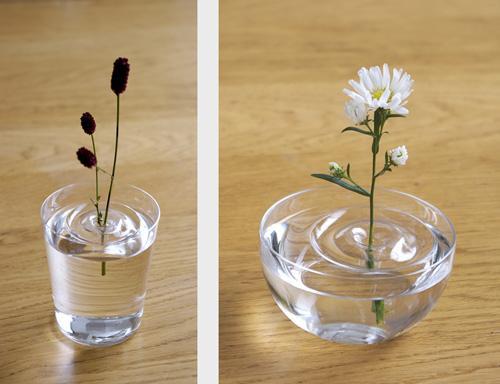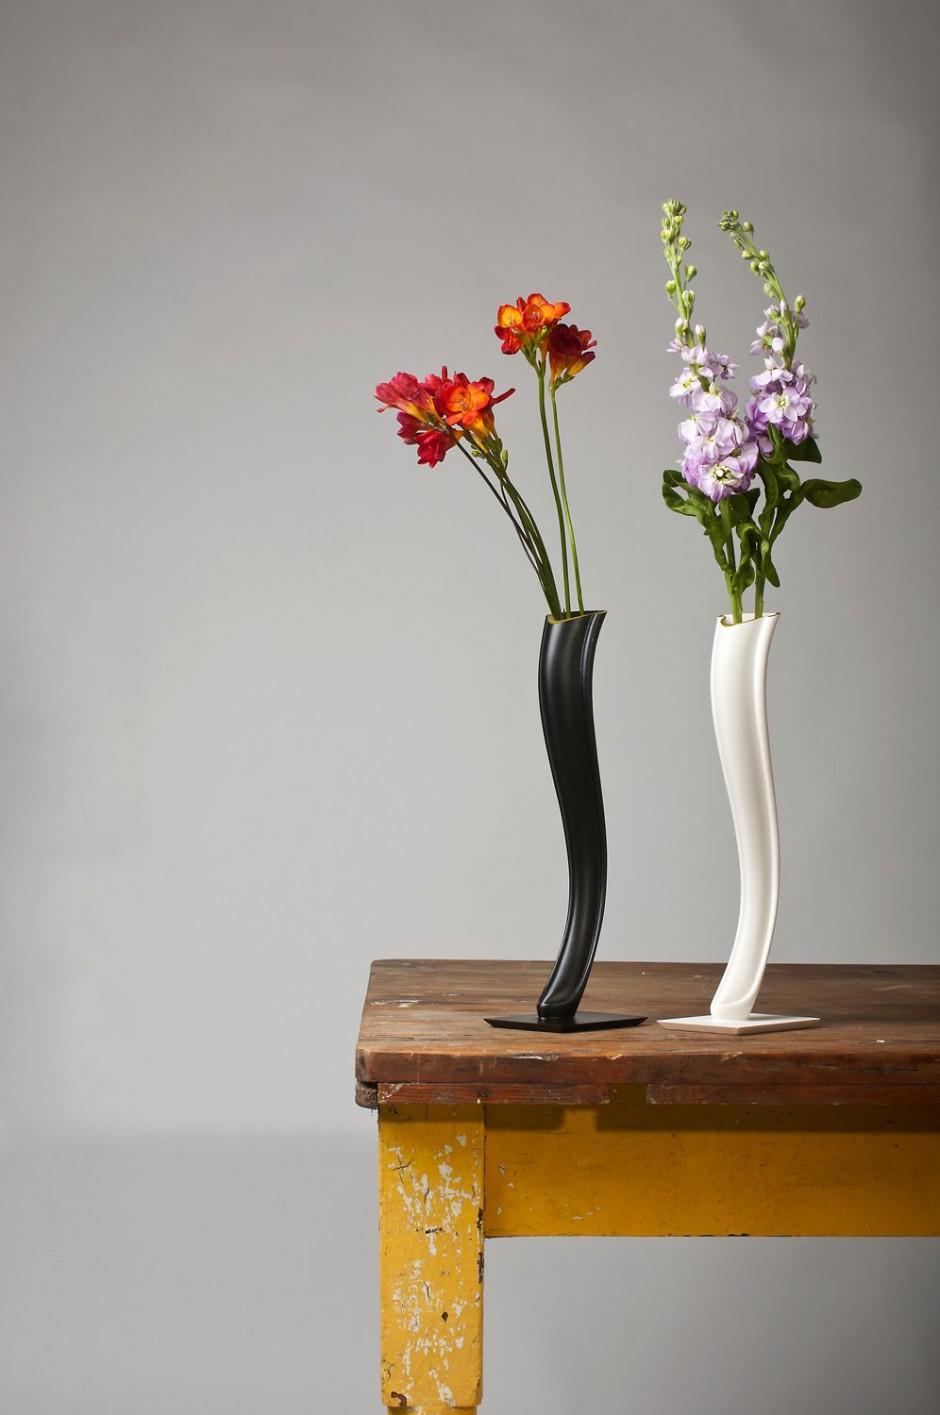The first image is the image on the left, the second image is the image on the right. Given the left and right images, does the statement "The flower in the white vase on the right is yellow." hold true? Answer yes or no. No. 